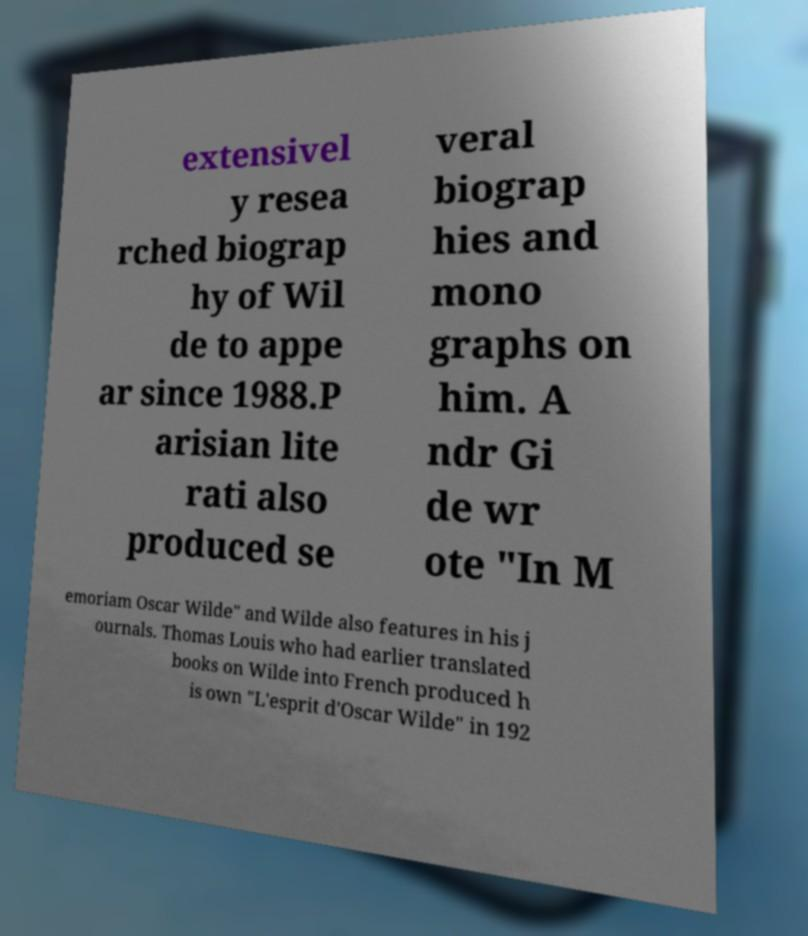Could you assist in decoding the text presented in this image and type it out clearly? extensivel y resea rched biograp hy of Wil de to appe ar since 1988.P arisian lite rati also produced se veral biograp hies and mono graphs on him. A ndr Gi de wr ote "In M emoriam Oscar Wilde" and Wilde also features in his j ournals. Thomas Louis who had earlier translated books on Wilde into French produced h is own "L'esprit d'Oscar Wilde" in 192 